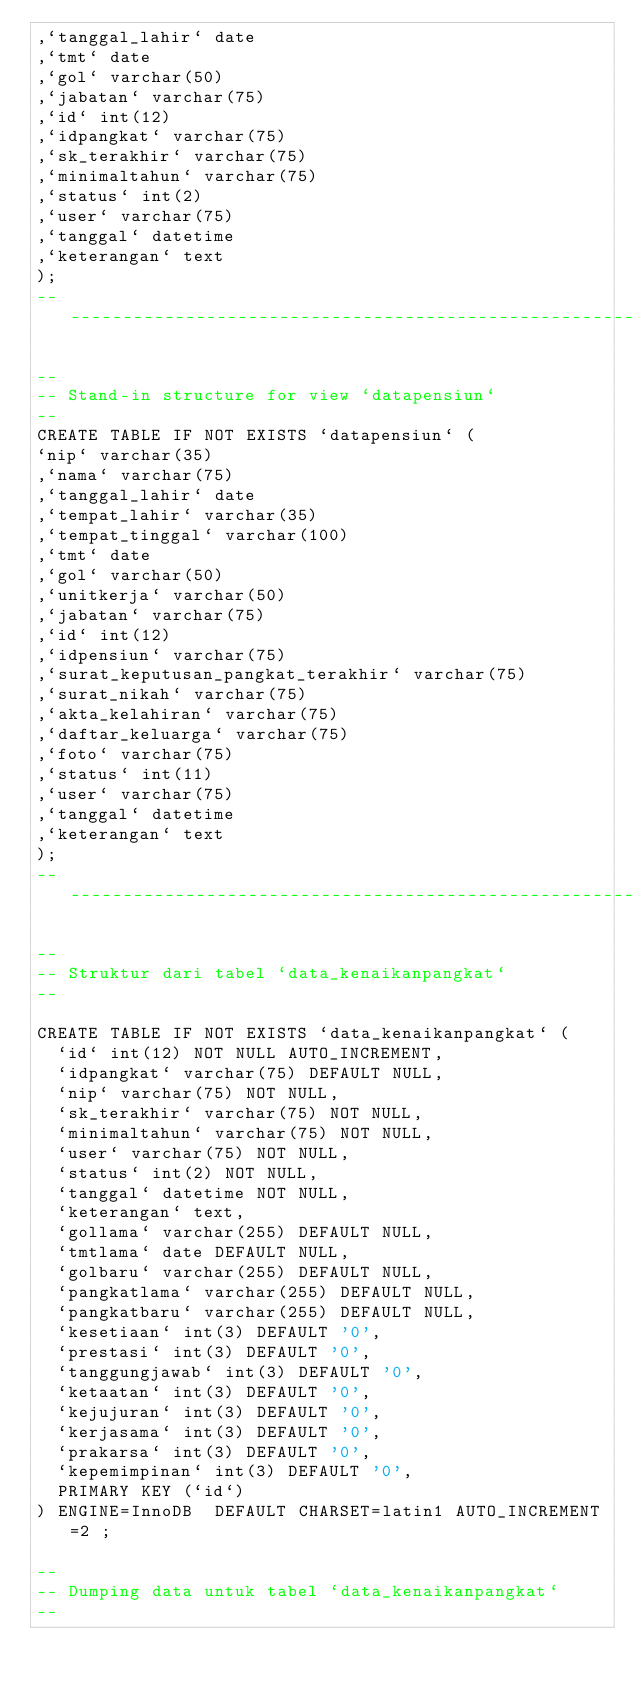Convert code to text. <code><loc_0><loc_0><loc_500><loc_500><_SQL_>,`tanggal_lahir` date
,`tmt` date
,`gol` varchar(50)
,`jabatan` varchar(75)
,`id` int(12)
,`idpangkat` varchar(75)
,`sk_terakhir` varchar(75)
,`minimaltahun` varchar(75)
,`status` int(2)
,`user` varchar(75)
,`tanggal` datetime
,`keterangan` text
);
-- --------------------------------------------------------

--
-- Stand-in structure for view `datapensiun`
--
CREATE TABLE IF NOT EXISTS `datapensiun` (
`nip` varchar(35)
,`nama` varchar(75)
,`tanggal_lahir` date
,`tempat_lahir` varchar(35)
,`tempat_tinggal` varchar(100)
,`tmt` date
,`gol` varchar(50)
,`unitkerja` varchar(50)
,`jabatan` varchar(75)
,`id` int(12)
,`idpensiun` varchar(75)
,`surat_keputusan_pangkat_terakhir` varchar(75)
,`surat_nikah` varchar(75)
,`akta_kelahiran` varchar(75)
,`daftar_keluarga` varchar(75)
,`foto` varchar(75)
,`status` int(11)
,`user` varchar(75)
,`tanggal` datetime
,`keterangan` text
);
-- --------------------------------------------------------

--
-- Struktur dari tabel `data_kenaikanpangkat`
--

CREATE TABLE IF NOT EXISTS `data_kenaikanpangkat` (
  `id` int(12) NOT NULL AUTO_INCREMENT,
  `idpangkat` varchar(75) DEFAULT NULL,
  `nip` varchar(75) NOT NULL,
  `sk_terakhir` varchar(75) NOT NULL,
  `minimaltahun` varchar(75) NOT NULL,
  `user` varchar(75) NOT NULL,
  `status` int(2) NOT NULL,
  `tanggal` datetime NOT NULL,
  `keterangan` text,
  `gollama` varchar(255) DEFAULT NULL,
  `tmtlama` date DEFAULT NULL,
  `golbaru` varchar(255) DEFAULT NULL,
  `pangkatlama` varchar(255) DEFAULT NULL,
  `pangkatbaru` varchar(255) DEFAULT NULL,
  `kesetiaan` int(3) DEFAULT '0',
  `prestasi` int(3) DEFAULT '0',
  `tanggungjawab` int(3) DEFAULT '0',
  `ketaatan` int(3) DEFAULT '0',
  `kejujuran` int(3) DEFAULT '0',
  `kerjasama` int(3) DEFAULT '0',
  `prakarsa` int(3) DEFAULT '0',
  `kepemimpinan` int(3) DEFAULT '0',
  PRIMARY KEY (`id`)
) ENGINE=InnoDB  DEFAULT CHARSET=latin1 AUTO_INCREMENT=2 ;

--
-- Dumping data untuk tabel `data_kenaikanpangkat`
--
</code> 